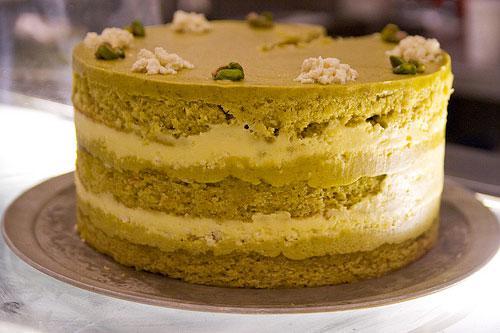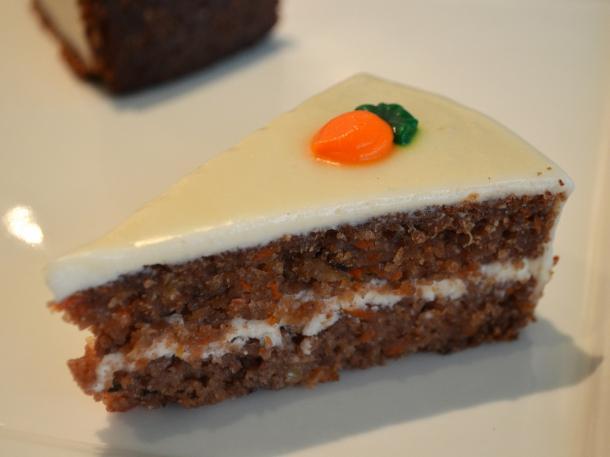The first image is the image on the left, the second image is the image on the right. For the images shown, is this caption "One image shows one dessert slice with white on its top, and the other image shows a dessert on a round plate consisting of round layers alternating with creamy layers." true? Answer yes or no. Yes. The first image is the image on the left, the second image is the image on the right. Examine the images to the left and right. Is the description "A cake with multiple layers is sitting on a plate in one image, while a single serving of a different dessert in the second image." accurate? Answer yes or no. Yes. 